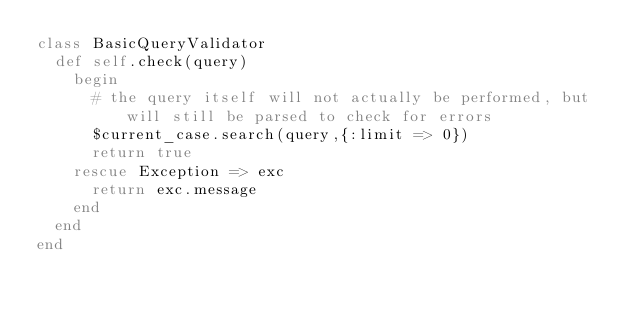<code> <loc_0><loc_0><loc_500><loc_500><_Ruby_>class BasicQueryValidator
	def self.check(query)
		begin
			# the query itself will not actually be performed, but will still be parsed to check for errors
			$current_case.search(query,{:limit => 0})
			return true
		rescue Exception => exc
			return exc.message
		end
	end
end</code> 